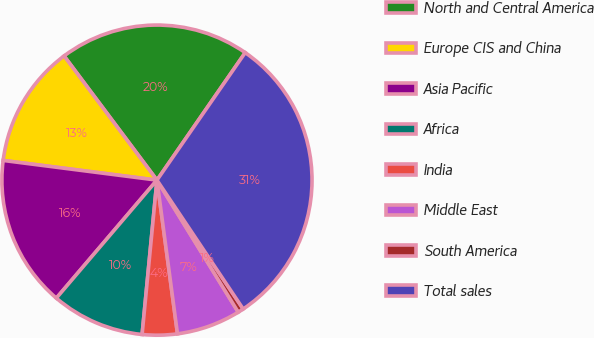Convert chart. <chart><loc_0><loc_0><loc_500><loc_500><pie_chart><fcel>North and Central America<fcel>Europe CIS and China<fcel>Asia Pacific<fcel>Africa<fcel>India<fcel>Middle East<fcel>South America<fcel>Total sales<nl><fcel>19.86%<fcel>12.75%<fcel>15.79%<fcel>9.71%<fcel>3.64%<fcel>6.67%<fcel>0.6%<fcel>30.98%<nl></chart> 